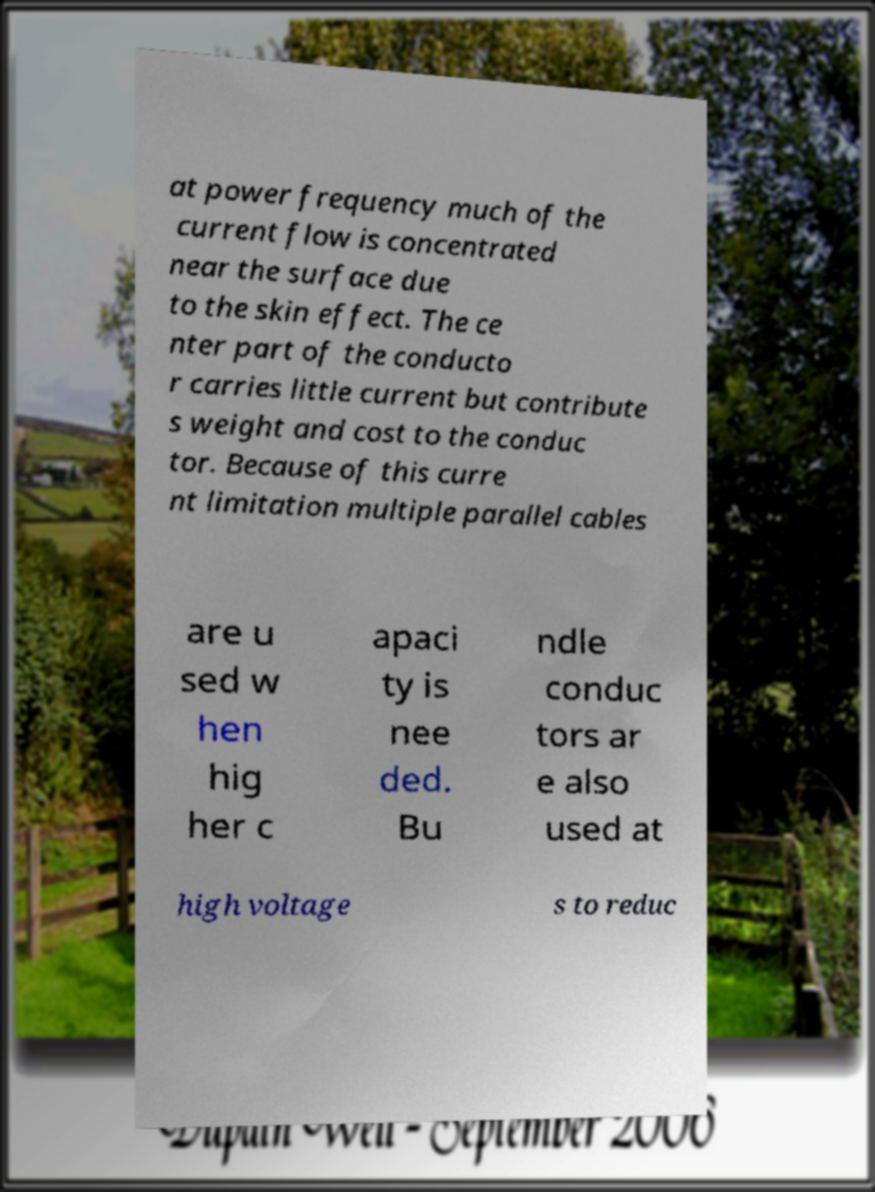I need the written content from this picture converted into text. Can you do that? at power frequency much of the current flow is concentrated near the surface due to the skin effect. The ce nter part of the conducto r carries little current but contribute s weight and cost to the conduc tor. Because of this curre nt limitation multiple parallel cables are u sed w hen hig her c apaci ty is nee ded. Bu ndle conduc tors ar e also used at high voltage s to reduc 